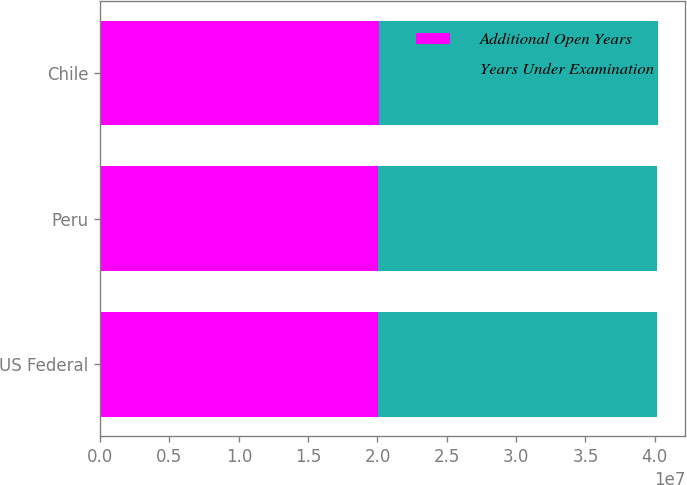Convert chart to OTSL. <chart><loc_0><loc_0><loc_500><loc_500><stacked_bar_chart><ecel><fcel>US Federal<fcel>Peru<fcel>Chile<nl><fcel>Additional Open Years<fcel>2.0072e+07<fcel>2.0022e+07<fcel>2.0102e+07<nl><fcel>Years Under Examination<fcel>2.0112e+07<fcel>2.0112e+07<fcel>2.0102e+07<nl></chart> 